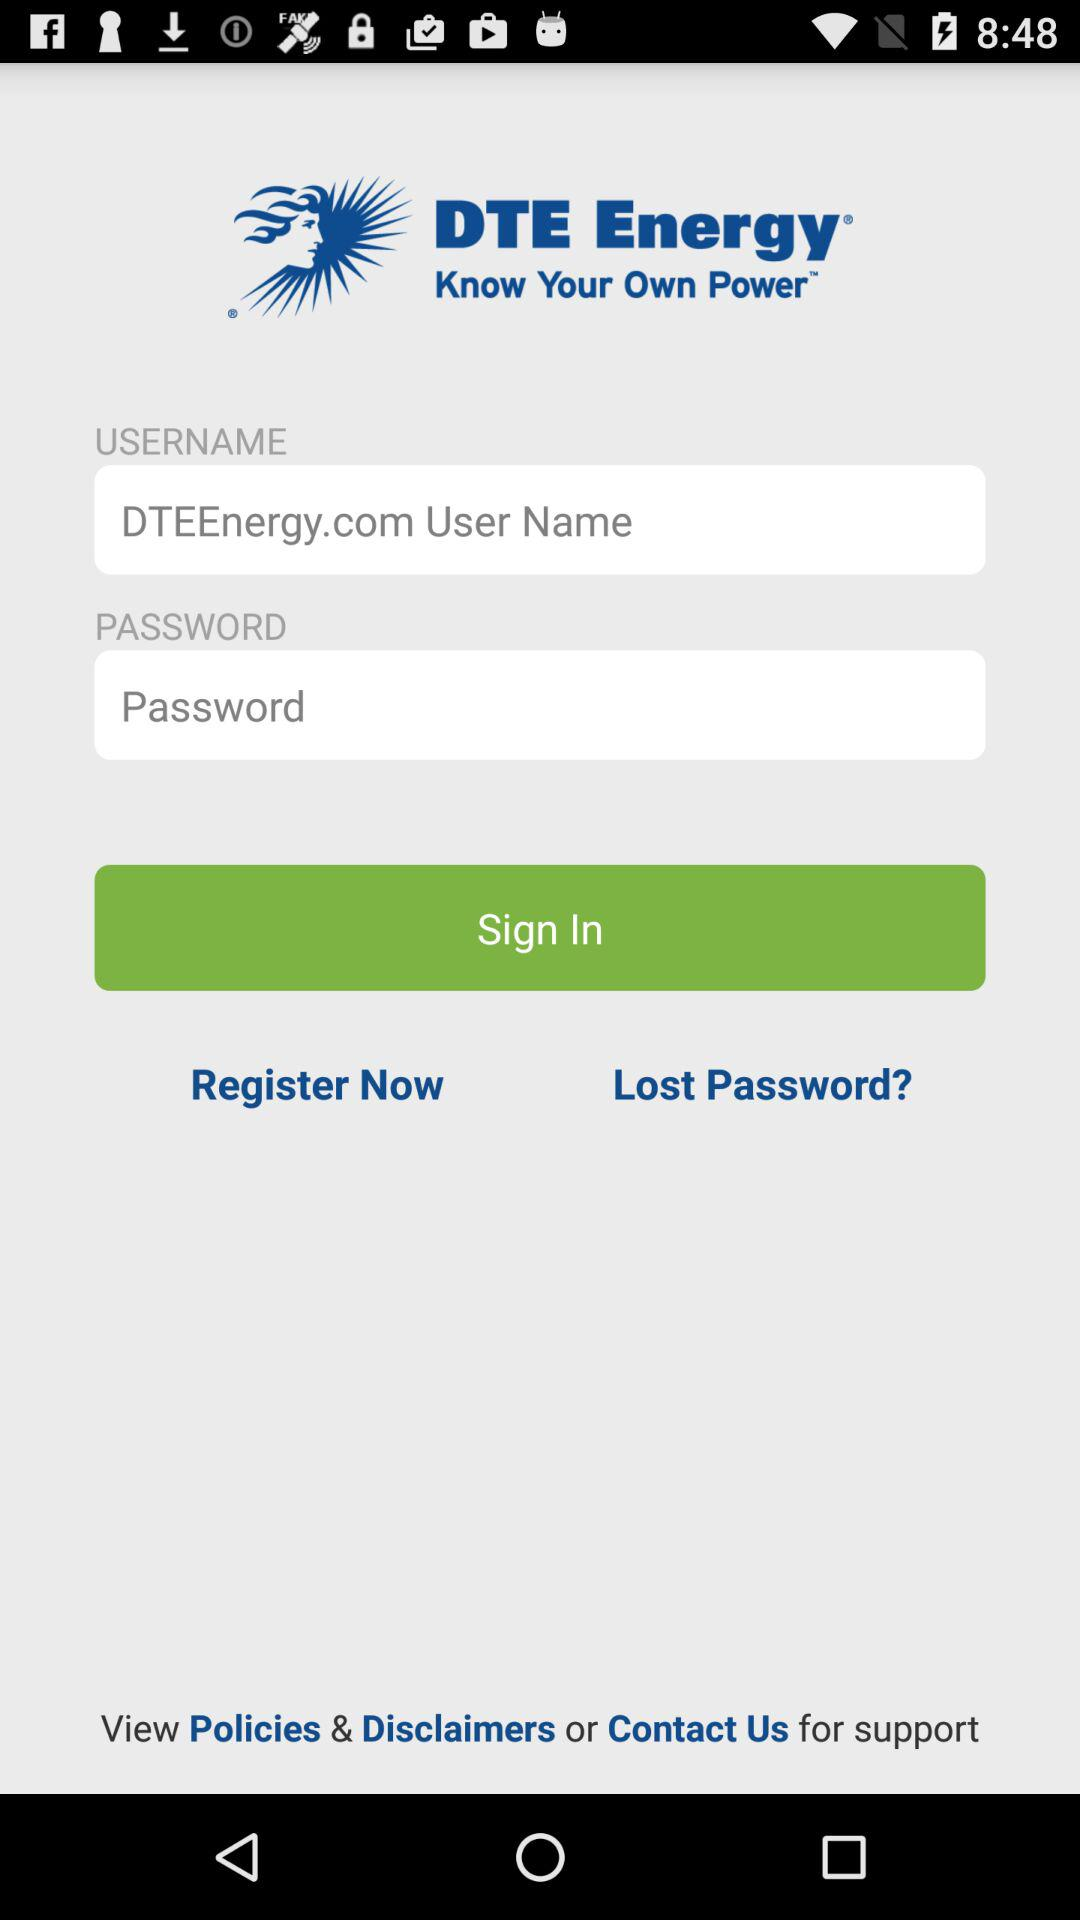What is the application name? The application name is "DTE Energy". 